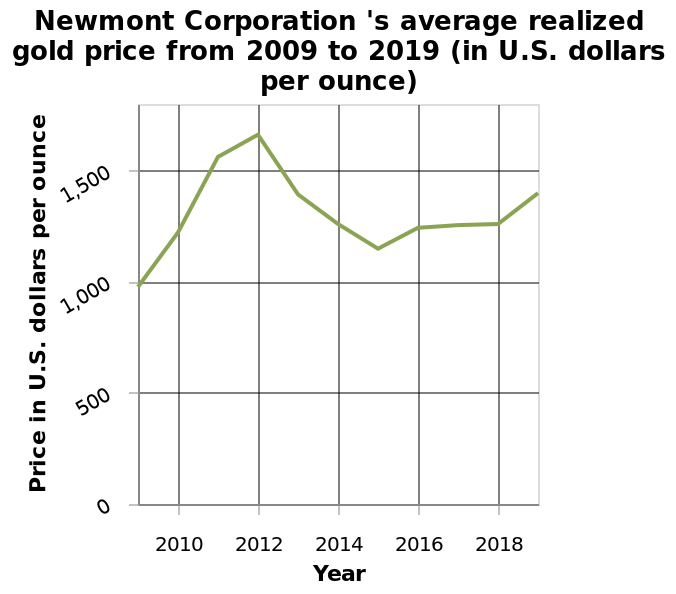<image>
What is the scale of the x-axis in the line chart representing Newmont Corporation's average realized gold price from 2009 to 2019? What is the scale of the x-axis in the line chart representing Newmont Corporation's average realized gold price from 2009 to 2019? Offer a thorough analysis of the image. Newmont Corporation's most successful year in the decade 2009 - 2019 was 2012 when they were able to achieve over $1500 per ounce of gold. For 3 years (2009 - 2012) the price steadily increased from $1000 to over $1500 before falling for the next 3 years to over $1100 per ounce. Prices began to rise again in 2015 but largely remained static at $1250 from 2016 to 2018 but have risen again in 2019 to around $1400, the second highest values in the decade. please enumerates aspects of the construction of the chart Newmont Corporation 's average realized gold price from 2009 to 2019 (in U.S. dollars per ounce) is a line chart. A linear scale from 0 to 1,500 can be found on the y-axis, marked Price in U.S. dollars per ounce. Year is defined as a linear scale of range 2010 to 2018 on the x-axis. 